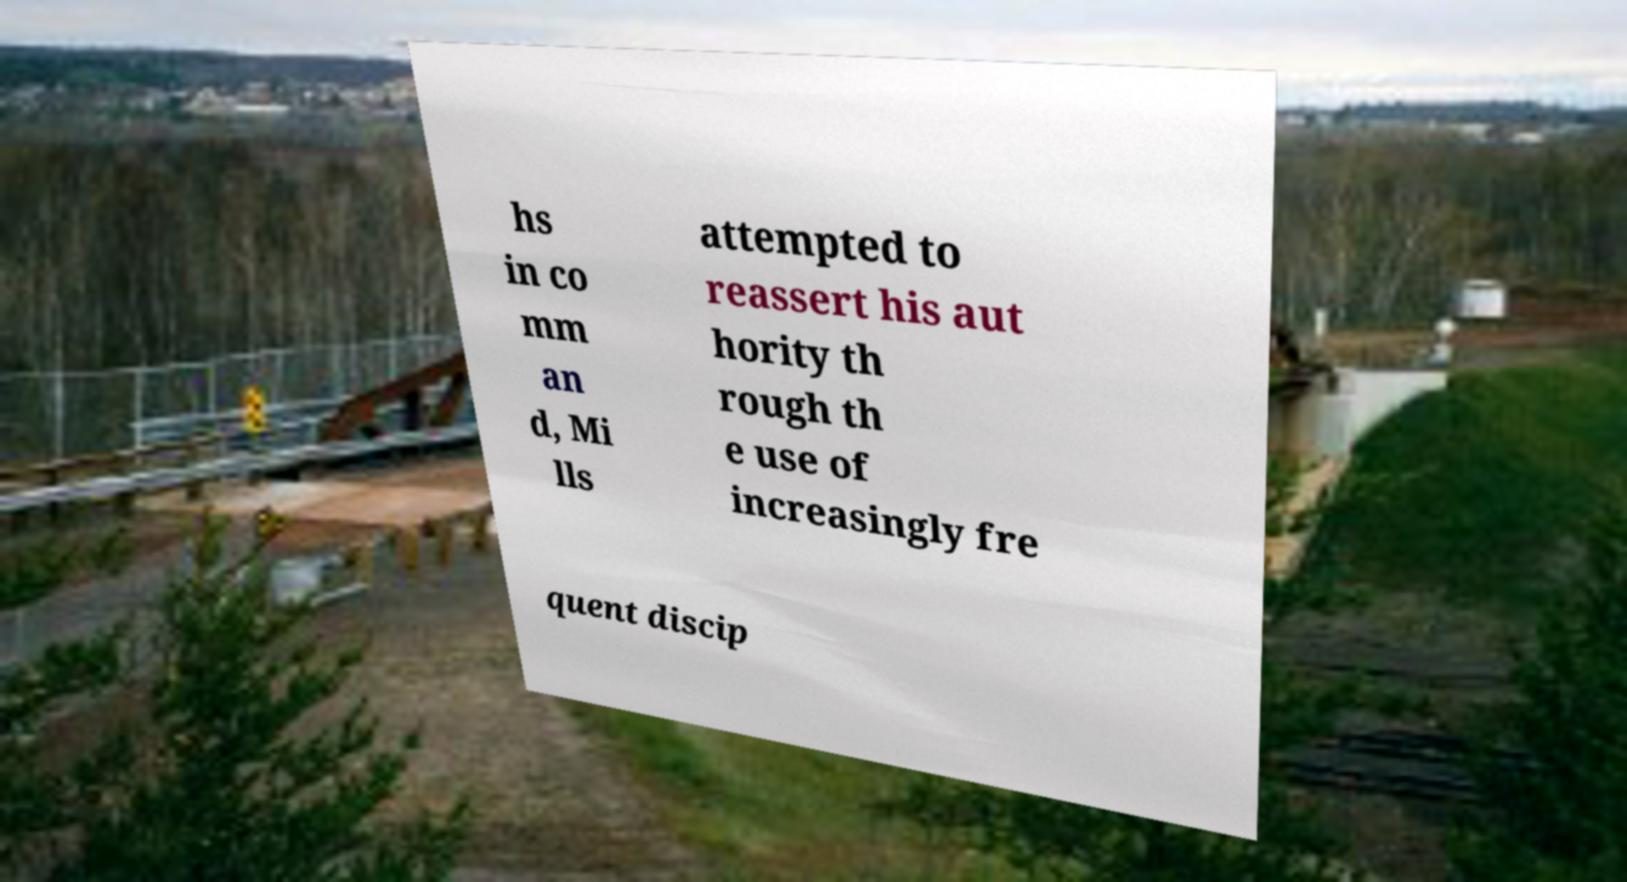Please read and relay the text visible in this image. What does it say? hs in co mm an d, Mi lls attempted to reassert his aut hority th rough th e use of increasingly fre quent discip 